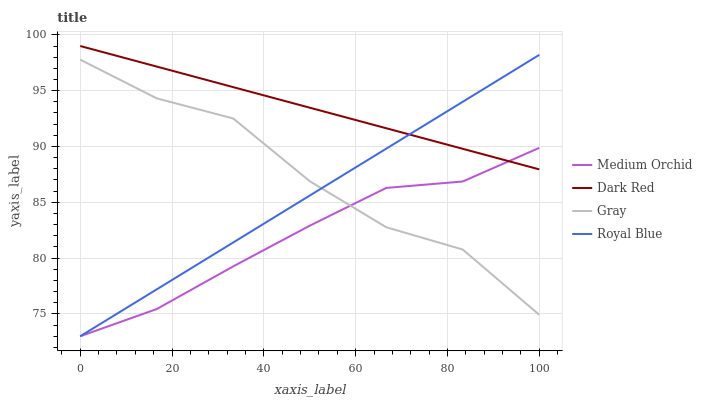Does Medium Orchid have the minimum area under the curve?
Answer yes or no. Yes. Does Dark Red have the maximum area under the curve?
Answer yes or no. Yes. Does Royal Blue have the minimum area under the curve?
Answer yes or no. No. Does Royal Blue have the maximum area under the curve?
Answer yes or no. No. Is Dark Red the smoothest?
Answer yes or no. Yes. Is Gray the roughest?
Answer yes or no. Yes. Is Medium Orchid the smoothest?
Answer yes or no. No. Is Medium Orchid the roughest?
Answer yes or no. No. Does Medium Orchid have the lowest value?
Answer yes or no. Yes. Does Gray have the lowest value?
Answer yes or no. No. Does Dark Red have the highest value?
Answer yes or no. Yes. Does Royal Blue have the highest value?
Answer yes or no. No. Is Gray less than Dark Red?
Answer yes or no. Yes. Is Dark Red greater than Gray?
Answer yes or no. Yes. Does Medium Orchid intersect Gray?
Answer yes or no. Yes. Is Medium Orchid less than Gray?
Answer yes or no. No. Is Medium Orchid greater than Gray?
Answer yes or no. No. Does Gray intersect Dark Red?
Answer yes or no. No. 